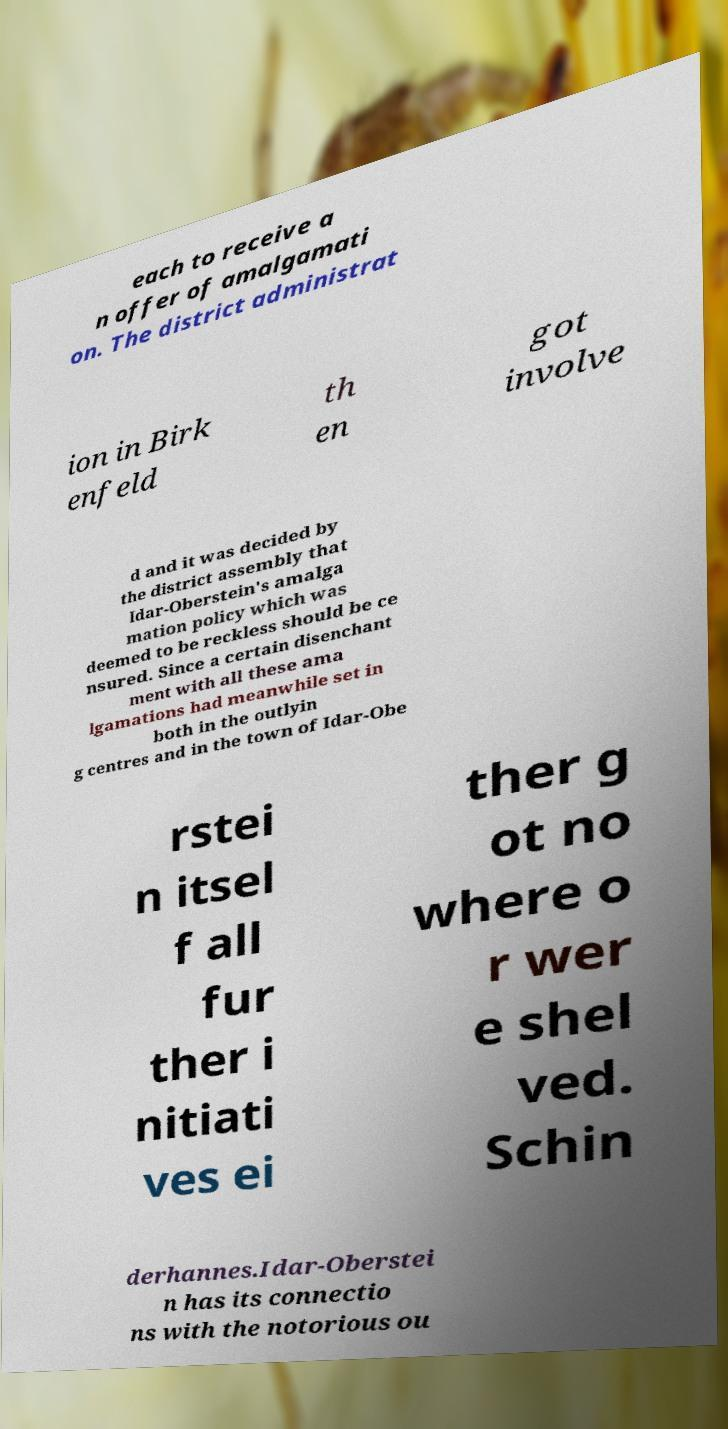What messages or text are displayed in this image? I need them in a readable, typed format. each to receive a n offer of amalgamati on. The district administrat ion in Birk enfeld th en got involve d and it was decided by the district assembly that Idar-Oberstein's amalga mation policy which was deemed to be reckless should be ce nsured. Since a certain disenchant ment with all these ama lgamations had meanwhile set in both in the outlyin g centres and in the town of Idar-Obe rstei n itsel f all fur ther i nitiati ves ei ther g ot no where o r wer e shel ved. Schin derhannes.Idar-Oberstei n has its connectio ns with the notorious ou 